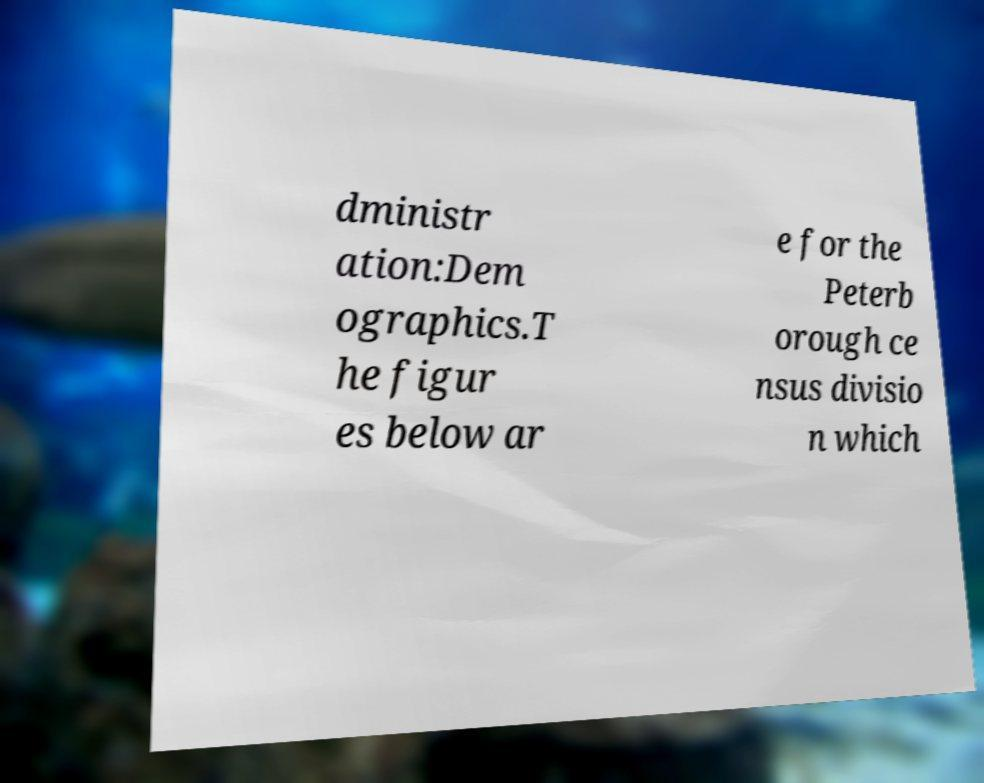For documentation purposes, I need the text within this image transcribed. Could you provide that? dministr ation:Dem ographics.T he figur es below ar e for the Peterb orough ce nsus divisio n which 